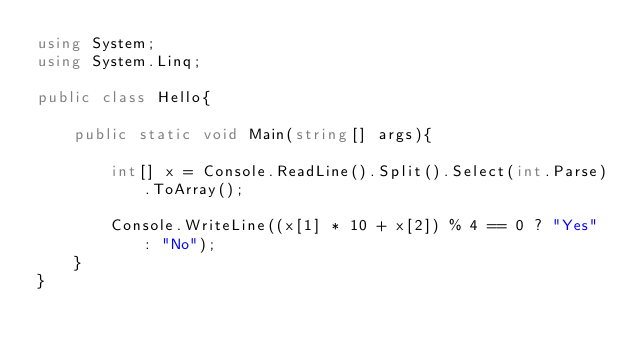<code> <loc_0><loc_0><loc_500><loc_500><_C#_>using System;
using System.Linq;

public class Hello{
    
    public static void Main(string[] args){
        
        int[] x = Console.ReadLine().Split().Select(int.Parse).ToArray();
        
        Console.WriteLine((x[1] * 10 + x[2]) % 4 == 0 ? "Yes" : "No");
    }
}</code> 